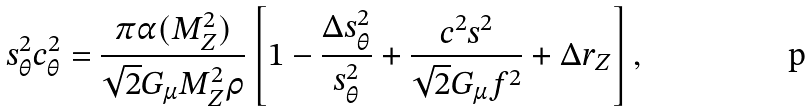Convert formula to latex. <formula><loc_0><loc_0><loc_500><loc_500>s _ { \theta } ^ { 2 } c _ { \theta } ^ { 2 } = \frac { \pi \alpha ( M _ { Z } ^ { 2 } ) } { \sqrt { 2 } G _ { \mu } M _ { Z } ^ { 2 } \rho } \left [ 1 - \frac { \Delta s _ { \theta } ^ { 2 } } { s _ { \theta } ^ { 2 } } + \frac { c ^ { 2 } s ^ { 2 } } { \sqrt { 2 } G _ { \mu } f ^ { 2 } } + \Delta r _ { Z } \right ] ,</formula> 